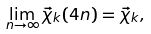Convert formula to latex. <formula><loc_0><loc_0><loc_500><loc_500>\lim _ { n \to \infty } \vec { \chi } _ { k } ( 4 n ) = \vec { \chi } _ { k } ,</formula> 